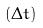<formula> <loc_0><loc_0><loc_500><loc_500>( \Delta t )</formula> 